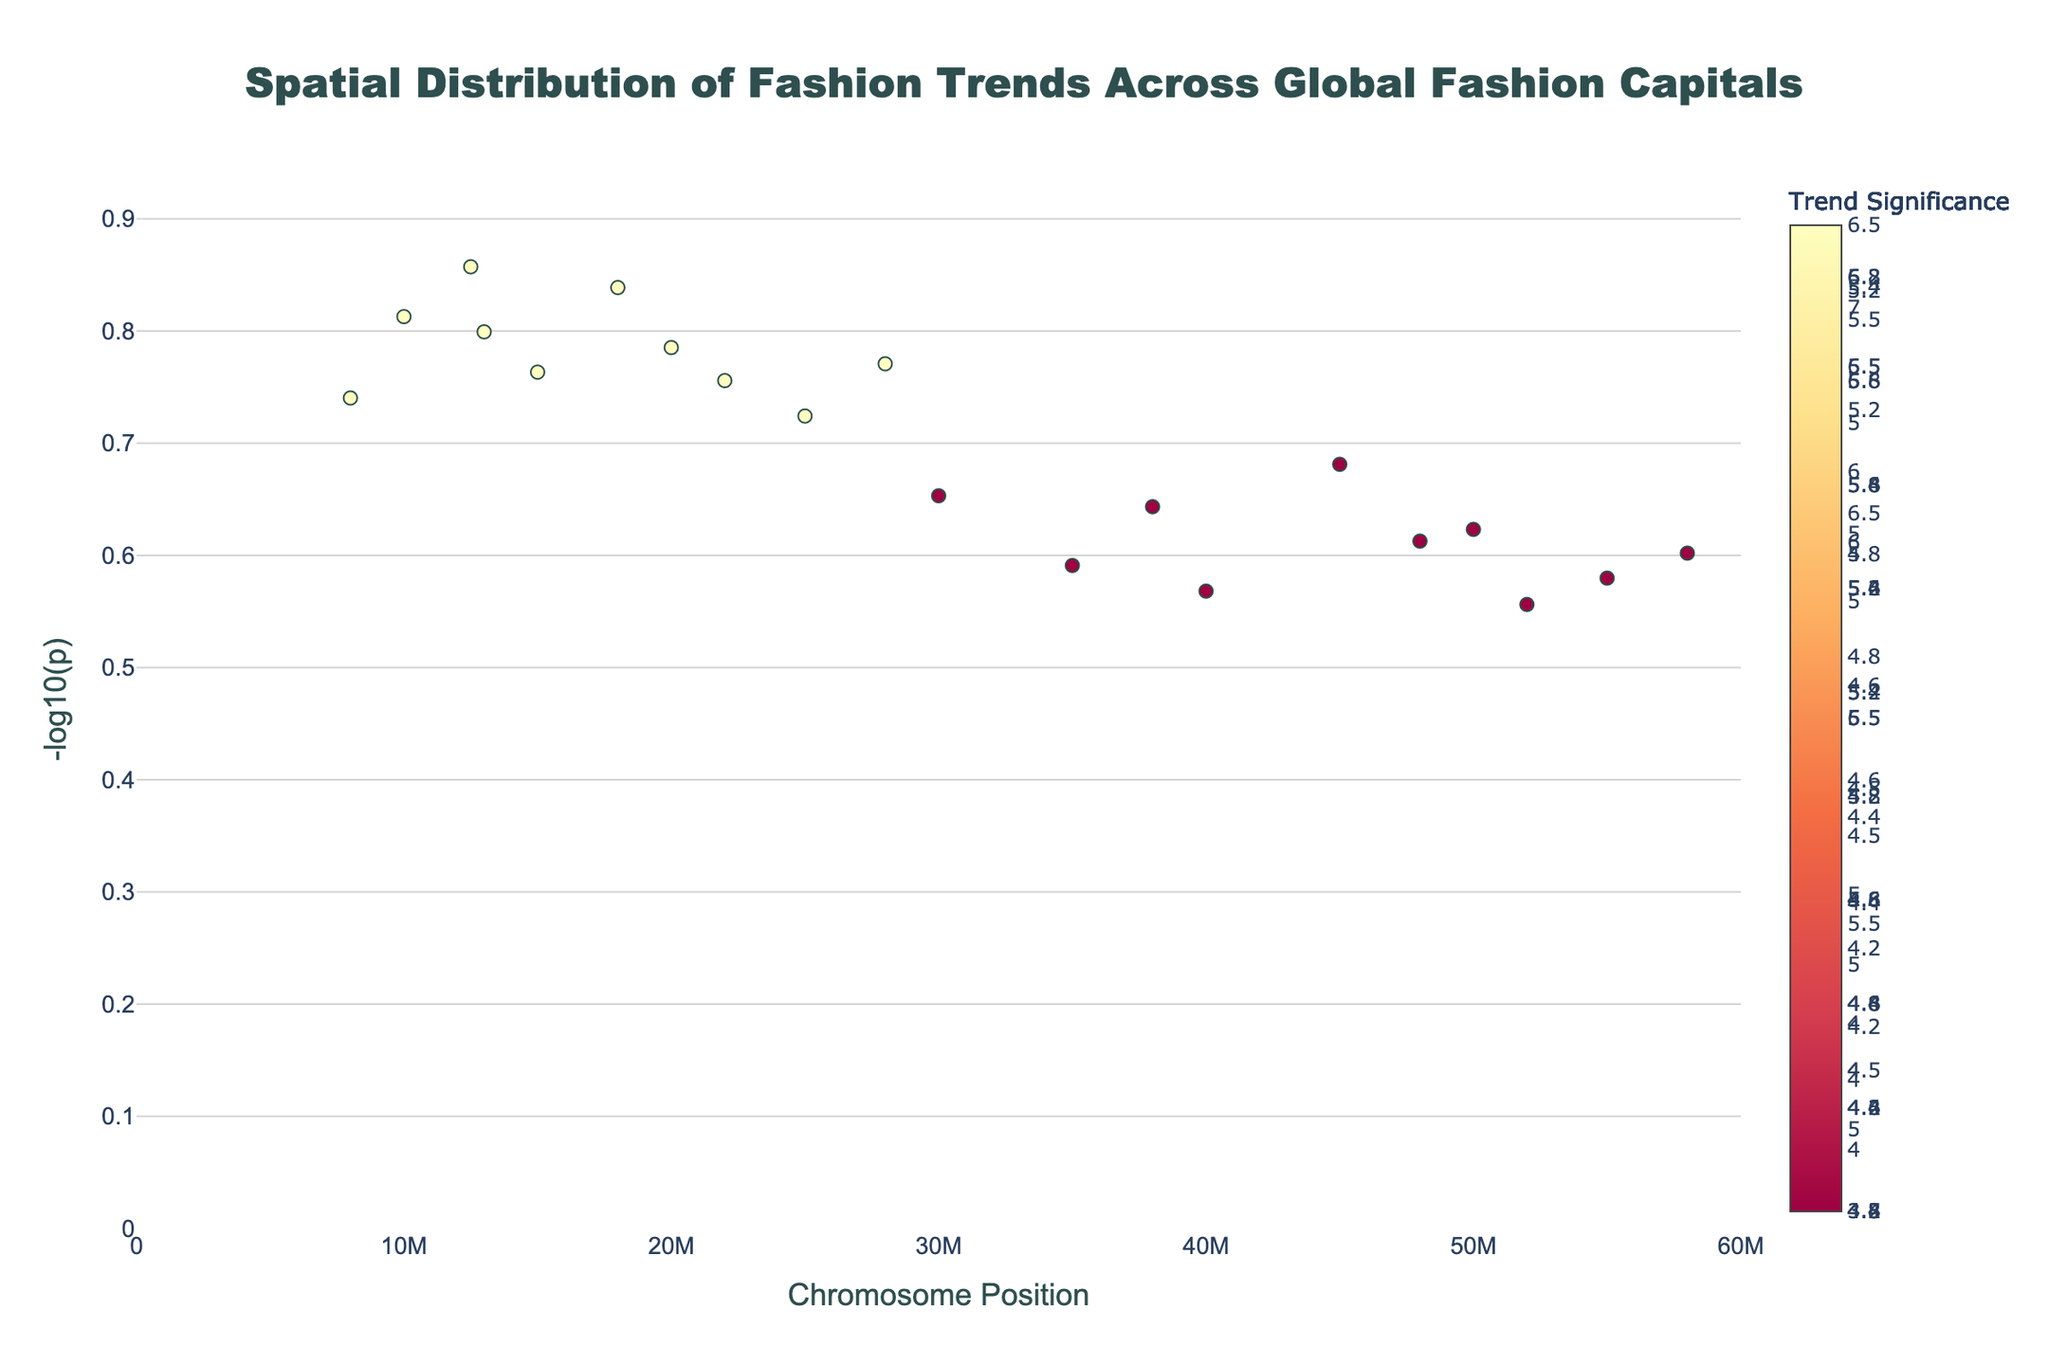What is the title of the figure? The title is usually found at the top of the figure. In this case, it is centered and in a larger font size compared to other text elements.
Answer: Spatial Distribution of Fashion Trends Across Global Fashion Capitals Which fashion capital has the highest trend significance on Chromosome 1? To answer this, find the data points under Chromosome 1, then identify the highest value on the y-axis (trend significance). The associated fashion capital can be read from the text shown on hover.
Answer: New York Based on Chromosome 5, which city focuses on upcycled structures, and what is its trend significance value? Look at Chromosome 5 and find the data point that corresponds to upcycled structures. Check the hover text to identify the city and note the trend significance associated with it.
Answer: Amsterdam, 4.5 What are the trend types that have a trend significance between 6 and 7? To address this, scan the y-axis values to find points within the range of 6 to 7. Then, read the hover text for each of these points to capture the associated trend types.
Answer: Structural Silhouettes, Futuristic Fabrics, Avant-Garde Headpieces Compare the trend significances of architectural prints in London and geometric accessories in Milan. Which one is higher? Find the points for London (architectural prints) and Milan (geometric accessories) on the figure, then compare their y-axis values to determine which one is higher.
Answer: Architectural Prints (5.5) is higher than Geometric Accessories (3.9) How many data points are displayed on Chromosome 3? Look specifically at the section for Chromosome 3 and count the number of plotted points. Each point represents a data entry on that chromosome.
Answer: 2 What is the trend significance of sustainable materials in Stockholm, and on which chromosome is it located? Locate the data point representing Stockholm. Use the hover text to find the associated trend type (sustainable materials) and its y-axis value for trend significance. Identify the chromosome number from the x-axis location.
Answer: 6.5, Chromosome 5 Calculate the average trend significance of all fashion trends related to Chromosome 7. Identify all data points on Chromosome 7, sum their trend significance values, and divide by the number of points. The points and their values are: 6.9 (Shanghai) and 4.1 (Hong Kong). Average = (6.9 + 4.1) / 2 = 5.5
Answer: 5.5 Which chromosome hosts the fashion capital that has a focus on 3D-printed jewelry, and what is that capital? Locate the data point for 3D-printed jewelry by reading the hover text on the figure. Note its corresponding chromosome on the x-axis and the fashion capital from the text.
Answer: Chromosome 6, Barcelona 